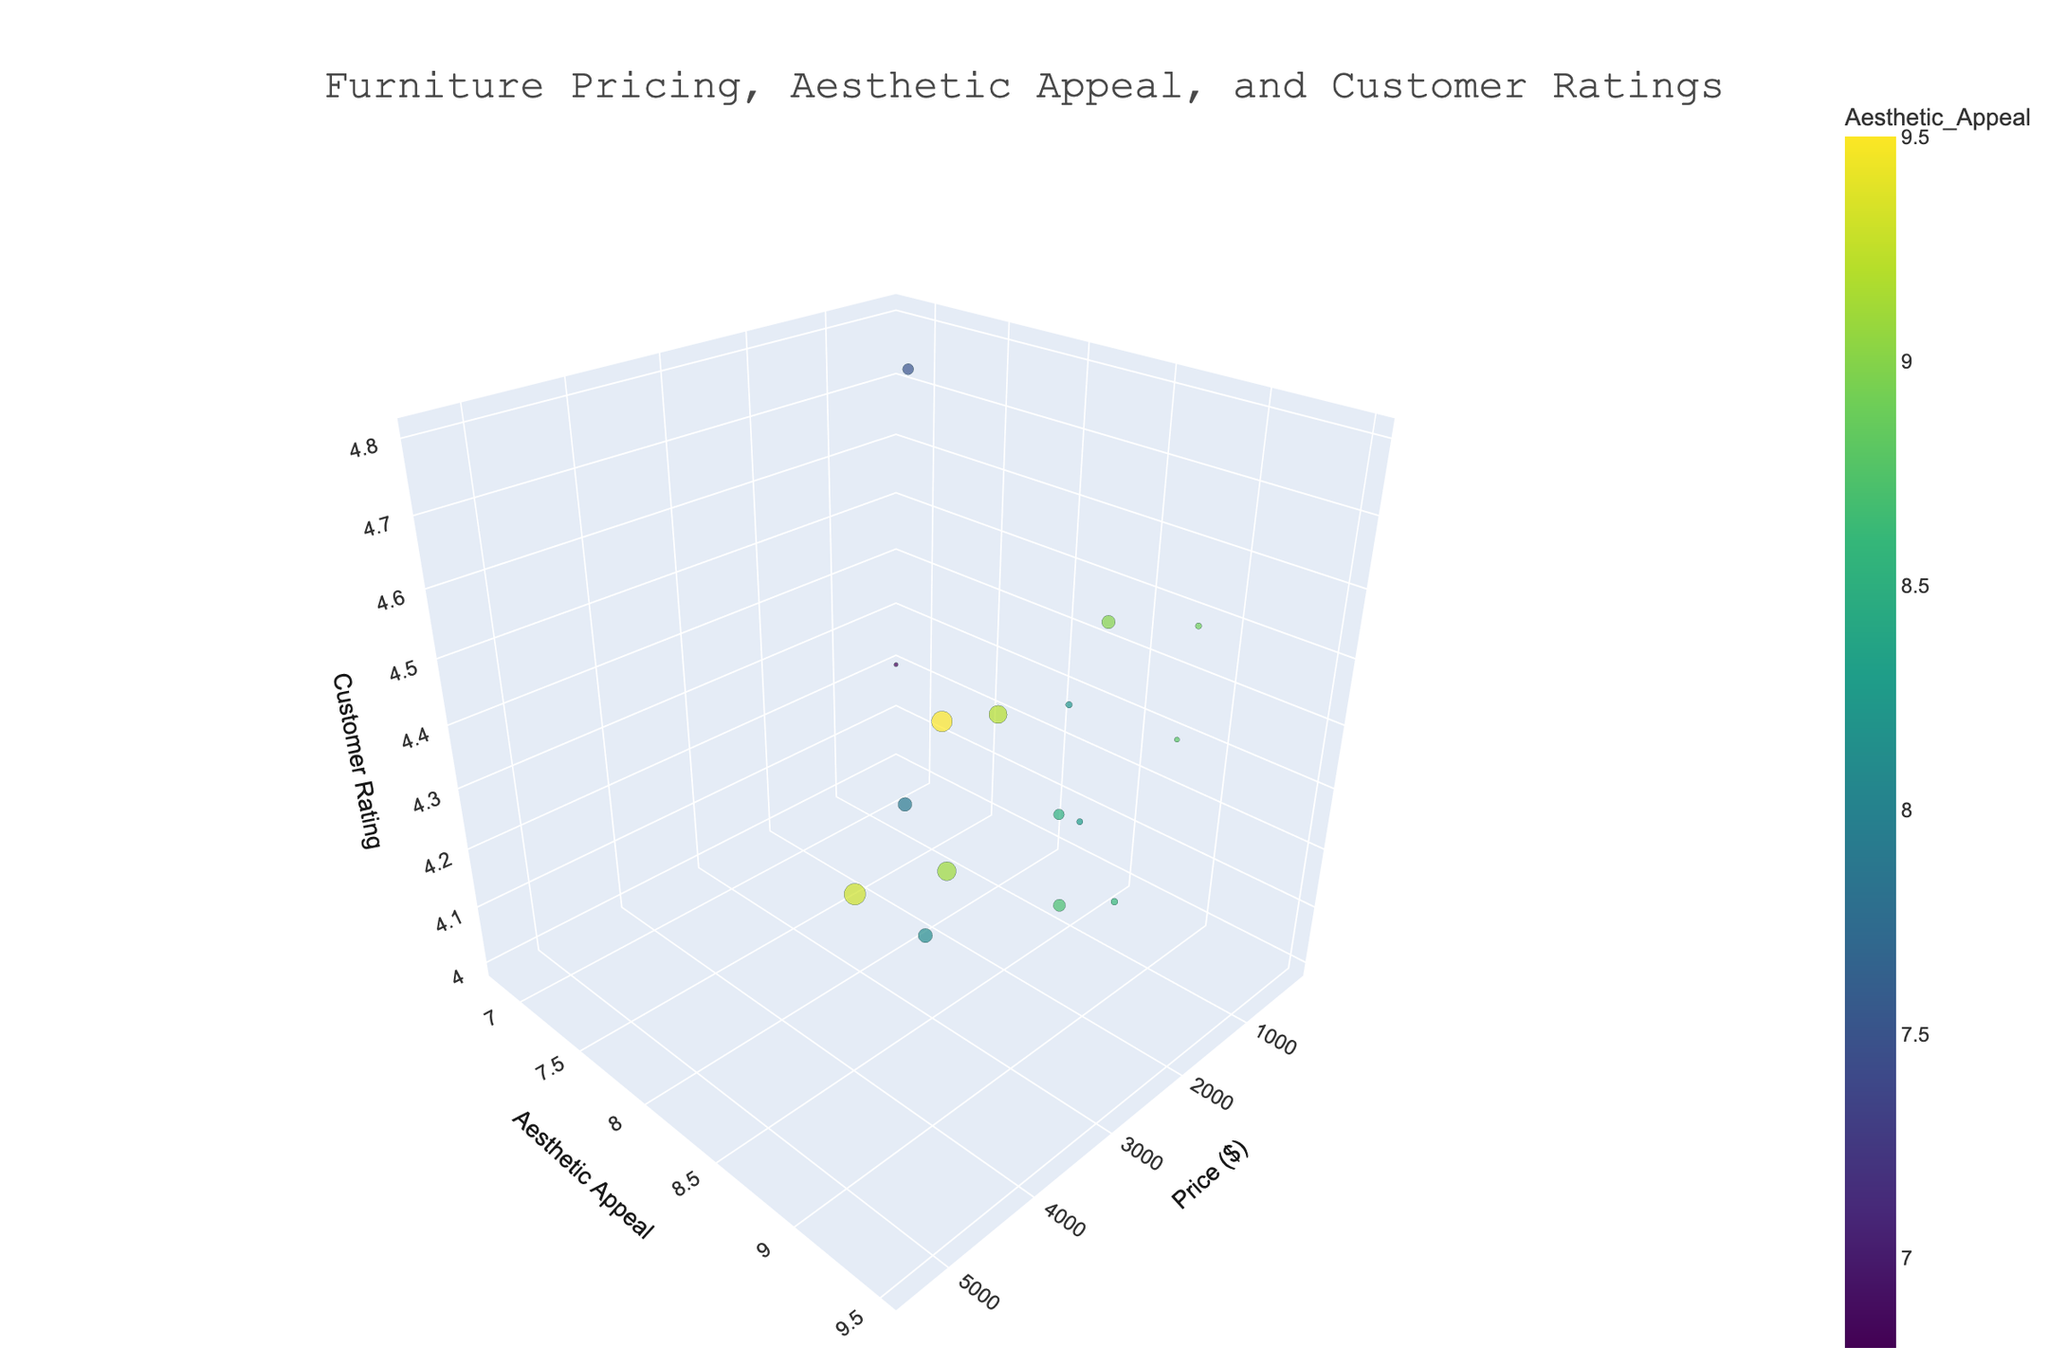What's the title of the plot? The title can be found at the top of the plot. It should be clearly written and usually designed to summarize the overall theme of the visualized data.
Answer: Furniture Pricing, Aesthetic Appeal, and Customer Ratings How many pieces of furniture are represented in the plot? To find this, count the unique data points (or markers) in the plot. Each represents a different furniture item based on the provided data. There are 16 pieces of furniture listed.
Answer: 16 Which furniture piece has the highest price? By looking at the x-axis, identify the point that is the furthest to the right, which typically represents the highest price. The 'Ligne Roset Togo Sofa' is priced at $5400 and is the furthest point on the x-axis.
Answer: Ligne Roset Togo Sofa What is the range of customer ratings in the plot? Check the spread of points along the z-axis to determine the minimum and maximum values for customer ratings. The ratings range from the lowest value of 4.0 to the highest of 4.8.
Answer: 4.0 to 4.8 Which furniture item has the highest aesthetic appeal, and what is its price? Locate the point with the highest y-value (aesthetic appeal). The 'Eames Lounge Chair' with an appeal score of 9.5 is the highest, and its price is $5000.
Answer: Eames Lounge Chair, $5000 Are there any points where high price and high aesthetic appeal do not correlate with high customer ratings? Look for points where high x (price) and y (aesthetic appeal) values result in lower z (customer rating) values. The 'Restoration Hardware Cloud Couch', priced at $4095 with an aesthetic appeal of 9.1, has a lower customer rating of 4.4.
Answer: Restoration Hardware Cloud Couch What is the average customer rating of furniture items with an aesthetic appeal of 9.0 or higher? Identify points with a y-value (aesthetic appeal) of 9.0 or higher, sum their z-values (customer ratings), and divide by the number of such points. 'Eames Lounge Chair' (4.7), 'Knoll Womb Chair' (4.6), 'Restoration Hardware Cloud Couch' (4.4), 'Ligne Roset Togo Sofa' (4.5), 'Noguchi Coffee Table' (4.6) are the relevant points, so average is (4.7+4.6+4.4+4.5+4.6)/5 = 4.56.
Answer: 4.56 Which furniture pieces have customer ratings of exactly 4.2, and what are their aesthetic appeal scores? Locate points on the z-axis at 4.2, and check their corresponding y-values for aesthetic appeal. 'IKEA POÄNG', 'Design Within Reach Nelson Bench', and 'Pottery Barn York Slipcovered Sofa' have ratings of 4.2 with aesthetic appeal scores of 6.8, 8.5, and 7.9, respectively.
Answer: IKEA POÄNG: 6.8, Design Within Reach Nelson Bench: 8.5, Pottery Barn York Slipcovered Sofa: 7.9 